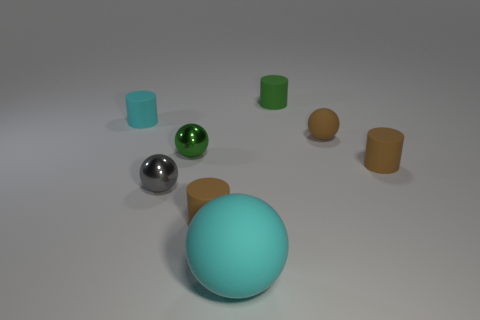Are there any other things that are the same color as the big matte thing?
Provide a succinct answer. Yes. Do the small ball that is in front of the green metallic sphere and the tiny green ball have the same material?
Offer a terse response. Yes. Are there the same number of green matte cylinders on the left side of the green matte object and tiny matte balls in front of the large cyan sphere?
Your answer should be compact. Yes. How big is the brown matte object behind the tiny thing right of the brown rubber ball?
Your response must be concise. Small. There is a brown thing that is both in front of the green metal thing and to the right of the green rubber thing; what is its material?
Provide a short and direct response. Rubber. How many other objects are there of the same size as the gray ball?
Provide a short and direct response. 6. The big matte object has what color?
Your answer should be compact. Cyan. Is the color of the matte thing that is to the left of the gray metallic object the same as the rubber sphere behind the big thing?
Provide a succinct answer. No. The brown ball is what size?
Ensure brevity in your answer.  Small. There is a rubber sphere on the left side of the brown matte ball; what size is it?
Provide a short and direct response. Large. 